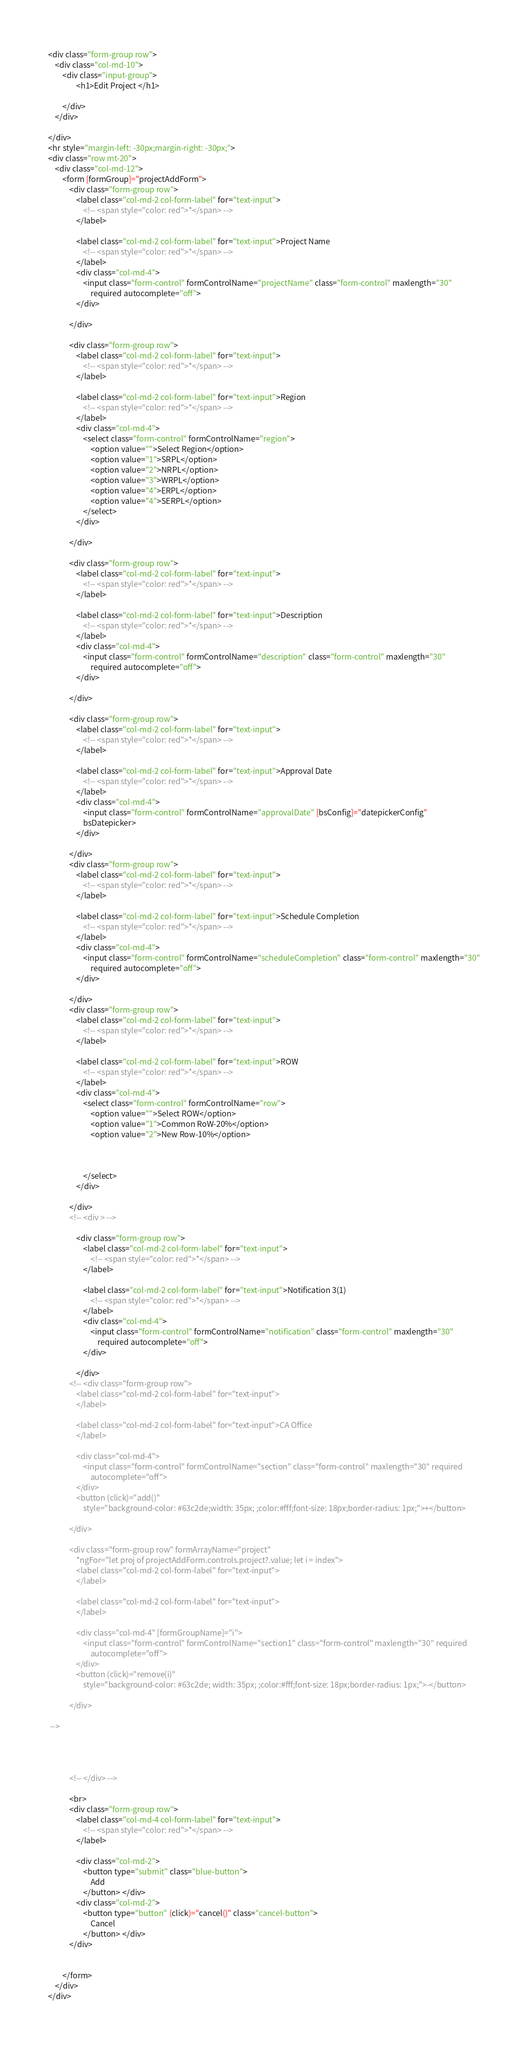<code> <loc_0><loc_0><loc_500><loc_500><_HTML_>
<div class="form-group row">
    <div class="col-md-10">
        <div class="input-group">
                <h1>Edit Project </h1>

        </div>
    </div>

</div>
<hr style="margin-left: -30px;margin-right: -30px;">
<div class="row mt-20">
    <div class="col-md-12">
        <form [formGroup]="projectAddForm">
            <div class="form-group row">
                <label class="col-md-2 col-form-label" for="text-input">
                    <!-- <span style="color: red">*</span> -->
                </label>

                <label class="col-md-2 col-form-label" for="text-input">Project Name
                    <!-- <span style="color: red">*</span> -->
                </label>
                <div class="col-md-4">
                    <input class="form-control" formControlName="projectName" class="form-control" maxlength="30"
                        required autocomplete="off">
                </div>

            </div>

            <div class="form-group row">
                <label class="col-md-2 col-form-label" for="text-input">
                    <!-- <span style="color: red">*</span> -->
                </label>

                <label class="col-md-2 col-form-label" for="text-input">Region
                    <!-- <span style="color: red">*</span> -->
                </label>
                <div class="col-md-4">
                    <select class="form-control" formControlName="region">
                        <option value="">Select Region</option>
                        <option value="1">SRPL</option>
                        <option value="2">NRPL</option>
                        <option value="3">WRPL</option>
                        <option value="4">ERPL</option>
                        <option value="4">SERPL</option>
                    </select> 
                </div>

            </div>

            <div class="form-group row">
                <label class="col-md-2 col-form-label" for="text-input">
                    <!-- <span style="color: red">*</span> -->
                </label>

                <label class="col-md-2 col-form-label" for="text-input">Description
                    <!-- <span style="color: red">*</span> -->
                </label>
                <div class="col-md-4">
                    <input class="form-control" formControlName="description" class="form-control" maxlength="30"
                        required autocomplete="off">
                </div>

            </div>
            
            <div class="form-group row">
                <label class="col-md-2 col-form-label" for="text-input">
                    <!-- <span style="color: red">*</span> -->
                </label>

                <label class="col-md-2 col-form-label" for="text-input">Approval Date
                    <!-- <span style="color: red">*</span> -->
                </label>
                <div class="col-md-4">
                    <input class="form-control" formControlName="approvalDate" [bsConfig]="datepickerConfig"
                    bsDatepicker>
                </div>

            </div>
            <div class="form-group row">
                <label class="col-md-2 col-form-label" for="text-input">
                    <!-- <span style="color: red">*</span> -->
                </label>

                <label class="col-md-2 col-form-label" for="text-input">Schedule Completion
                    <!-- <span style="color: red">*</span> -->
                </label>
                <div class="col-md-4">
                    <input class="form-control" formControlName="scheduleCompletion" class="form-control" maxlength="30"
                        required autocomplete="off">
                </div>

            </div>
            <div class="form-group row">
                <label class="col-md-2 col-form-label" for="text-input">
                    <!-- <span style="color: red">*</span> -->
                </label>

                <label class="col-md-2 col-form-label" for="text-input">ROW
                    <!-- <span style="color: red">*</span> -->
                </label>
                <div class="col-md-4">
                    <select class="form-control" formControlName="row">
                        <option value="">Select ROW</option>
                        <option value="1">Common RoW-20%</option>
                        <option value="2">New Row-10%</option>
                       
                      

                    </select> 
                </div>

            </div>
            <!-- <div > -->

                <div class="form-group row">
                    <label class="col-md-2 col-form-label" for="text-input">
                        <!-- <span style="color: red">*</span> -->
                    </label>
    
                    <label class="col-md-2 col-form-label" for="text-input">Notification 3(1)
                        <!-- <span style="color: red">*</span> -->
                    </label>
                    <div class="col-md-4">
                        <input class="form-control" formControlName="notification" class="form-control" maxlength="30"
                            required autocomplete="off">
                    </div>
    
                </div>
            <!-- <div class="form-group row">
                <label class="col-md-2 col-form-label" for="text-input">
                </label>

                <label class="col-md-2 col-form-label" for="text-input">CA Office
                </label>

                <div class="col-md-4">
                    <input class="form-control" formControlName="section" class="form-control" maxlength="30" required
                        autocomplete="off">
                </div>
                <button (click)="add()"
                    style="background-color: #63c2de;width: 35px; ;color:#fff;font-size: 18px;border-radius: 1px;">+</button>

            </div>

            <div class="form-group row" formArrayName="project"
                *ngFor="let proj of projectAddForm.controls.project?.value; let i = index">
                <label class="col-md-2 col-form-label" for="text-input">
                </label>

                <label class="col-md-2 col-form-label" for="text-input">
                </label>

                <div class="col-md-4" [formGroupName]="i">
                    <input class="form-control" formControlName="section1" class="form-control" maxlength="30" required
                        autocomplete="off">
                </div>
                <button (click)="remove(i)"
                    style="background-color: #63c2de; width: 35px; ;color:#fff;font-size: 18px;border-radius: 1px;">-</button>

            </div>

 -->




            <!-- </div> -->

            <br>
            <div class="form-group row">
                <label class="col-md-4 col-form-label" for="text-input">
                    <!-- <span style="color: red">*</span> -->
                </label>

                <div class="col-md-2">
                    <button type="submit" class="blue-button">
                        Add
                    </button> </div>
                <div class="col-md-2">
                    <button type="button" (click)="cancel()" class="cancel-button">
                        Cancel
                    </button> </div>
            </div>


        </form>
    </div>
</div></code> 